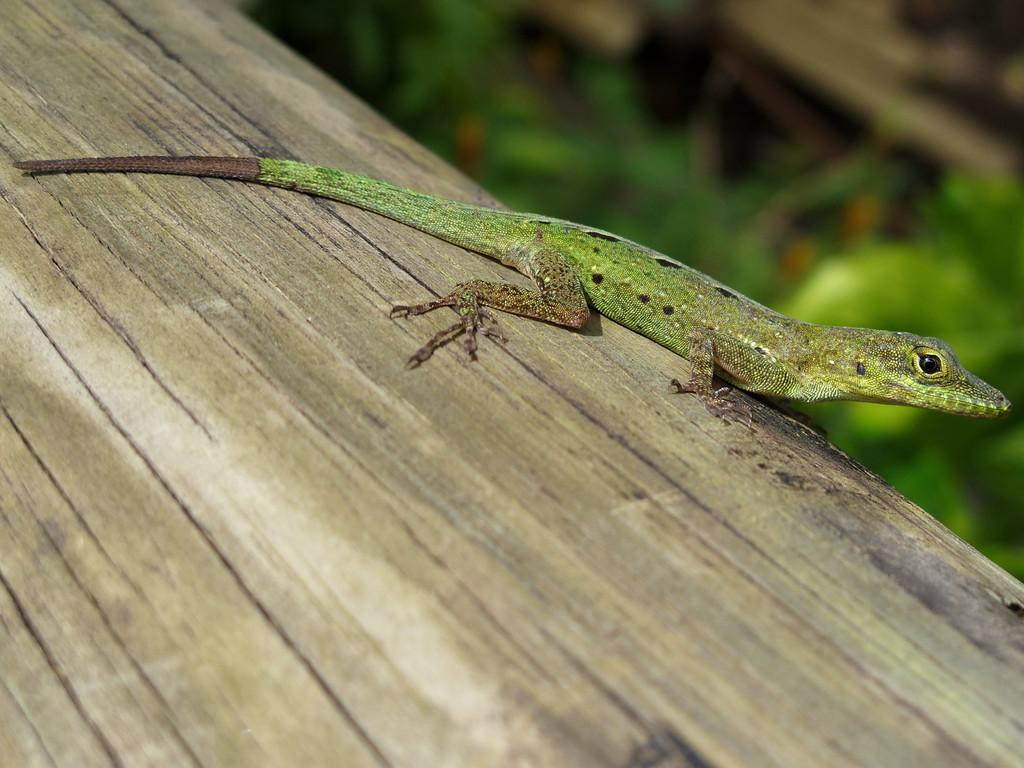What type of animal is in the image? There is a lizard in the image. What surface is the lizard on? The lizard is on wood. What can be seen in the background of the image? There are plants in the background of the image. When might this image have been taken? The image was likely taken during the day, as there is sufficient light. What type of bed can be seen in the image? There is no bed present in the image; it features a lizard on wood with plants in the background. 